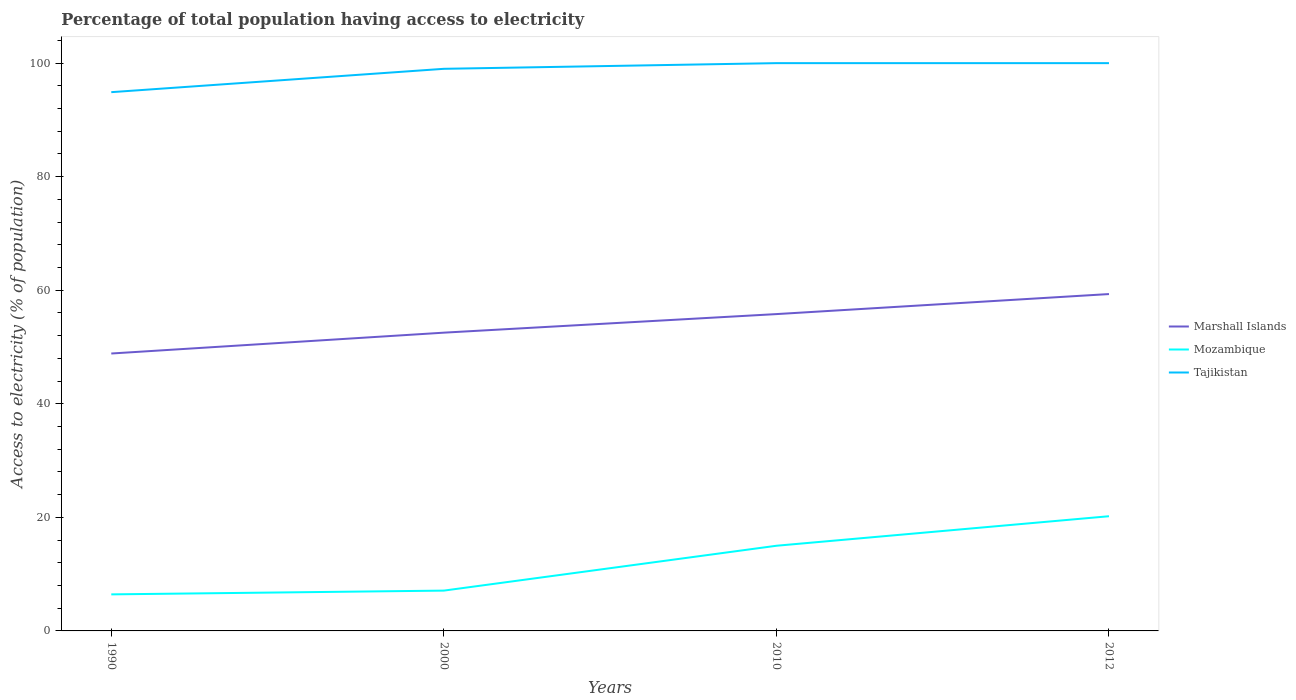Across all years, what is the maximum percentage of population that have access to electricity in Mozambique?
Provide a short and direct response. 6.44. In which year was the percentage of population that have access to electricity in Mozambique maximum?
Ensure brevity in your answer.  1990. What is the total percentage of population that have access to electricity in Marshall Islands in the graph?
Your response must be concise. -10.47. What is the difference between the highest and the second highest percentage of population that have access to electricity in Tajikistan?
Offer a very short reply. 5.11. What is the difference between the highest and the lowest percentage of population that have access to electricity in Mozambique?
Provide a succinct answer. 2. How many years are there in the graph?
Keep it short and to the point. 4. What is the difference between two consecutive major ticks on the Y-axis?
Offer a terse response. 20. Are the values on the major ticks of Y-axis written in scientific E-notation?
Offer a terse response. No. Does the graph contain any zero values?
Provide a succinct answer. No. Does the graph contain grids?
Your answer should be compact. No. How many legend labels are there?
Keep it short and to the point. 3. How are the legend labels stacked?
Ensure brevity in your answer.  Vertical. What is the title of the graph?
Offer a terse response. Percentage of total population having access to electricity. What is the label or title of the Y-axis?
Your answer should be compact. Access to electricity (% of population). What is the Access to electricity (% of population) of Marshall Islands in 1990?
Offer a very short reply. 48.86. What is the Access to electricity (% of population) of Mozambique in 1990?
Your response must be concise. 6.44. What is the Access to electricity (% of population) of Tajikistan in 1990?
Ensure brevity in your answer.  94.89. What is the Access to electricity (% of population) of Marshall Islands in 2000?
Provide a succinct answer. 52.53. What is the Access to electricity (% of population) of Marshall Islands in 2010?
Offer a very short reply. 55.8. What is the Access to electricity (% of population) in Mozambique in 2010?
Provide a succinct answer. 15. What is the Access to electricity (% of population) of Marshall Islands in 2012?
Your answer should be very brief. 59.33. What is the Access to electricity (% of population) of Mozambique in 2012?
Your response must be concise. 20.2. Across all years, what is the maximum Access to electricity (% of population) of Marshall Islands?
Offer a very short reply. 59.33. Across all years, what is the maximum Access to electricity (% of population) of Mozambique?
Offer a very short reply. 20.2. Across all years, what is the minimum Access to electricity (% of population) in Marshall Islands?
Provide a short and direct response. 48.86. Across all years, what is the minimum Access to electricity (% of population) of Mozambique?
Provide a short and direct response. 6.44. Across all years, what is the minimum Access to electricity (% of population) of Tajikistan?
Provide a short and direct response. 94.89. What is the total Access to electricity (% of population) of Marshall Islands in the graph?
Your answer should be compact. 216.52. What is the total Access to electricity (% of population) in Mozambique in the graph?
Your response must be concise. 48.74. What is the total Access to electricity (% of population) in Tajikistan in the graph?
Keep it short and to the point. 393.89. What is the difference between the Access to electricity (% of population) in Marshall Islands in 1990 and that in 2000?
Make the answer very short. -3.67. What is the difference between the Access to electricity (% of population) in Mozambique in 1990 and that in 2000?
Your response must be concise. -0.66. What is the difference between the Access to electricity (% of population) in Tajikistan in 1990 and that in 2000?
Provide a short and direct response. -4.11. What is the difference between the Access to electricity (% of population) of Marshall Islands in 1990 and that in 2010?
Provide a short and direct response. -6.94. What is the difference between the Access to electricity (% of population) of Mozambique in 1990 and that in 2010?
Provide a succinct answer. -8.56. What is the difference between the Access to electricity (% of population) of Tajikistan in 1990 and that in 2010?
Provide a short and direct response. -5.11. What is the difference between the Access to electricity (% of population) in Marshall Islands in 1990 and that in 2012?
Offer a very short reply. -10.47. What is the difference between the Access to electricity (% of population) in Mozambique in 1990 and that in 2012?
Keep it short and to the point. -13.76. What is the difference between the Access to electricity (% of population) of Tajikistan in 1990 and that in 2012?
Your answer should be very brief. -5.11. What is the difference between the Access to electricity (% of population) of Marshall Islands in 2000 and that in 2010?
Your response must be concise. -3.27. What is the difference between the Access to electricity (% of population) in Tajikistan in 2000 and that in 2010?
Give a very brief answer. -1. What is the difference between the Access to electricity (% of population) in Marshall Islands in 2000 and that in 2012?
Provide a short and direct response. -6.8. What is the difference between the Access to electricity (% of population) of Mozambique in 2000 and that in 2012?
Give a very brief answer. -13.1. What is the difference between the Access to electricity (% of population) of Marshall Islands in 2010 and that in 2012?
Ensure brevity in your answer.  -3.53. What is the difference between the Access to electricity (% of population) of Mozambique in 2010 and that in 2012?
Your answer should be compact. -5.2. What is the difference between the Access to electricity (% of population) in Marshall Islands in 1990 and the Access to electricity (% of population) in Mozambique in 2000?
Your response must be concise. 41.76. What is the difference between the Access to electricity (% of population) in Marshall Islands in 1990 and the Access to electricity (% of population) in Tajikistan in 2000?
Provide a succinct answer. -50.14. What is the difference between the Access to electricity (% of population) of Mozambique in 1990 and the Access to electricity (% of population) of Tajikistan in 2000?
Provide a succinct answer. -92.56. What is the difference between the Access to electricity (% of population) in Marshall Islands in 1990 and the Access to electricity (% of population) in Mozambique in 2010?
Your answer should be compact. 33.86. What is the difference between the Access to electricity (% of population) in Marshall Islands in 1990 and the Access to electricity (% of population) in Tajikistan in 2010?
Your answer should be very brief. -51.14. What is the difference between the Access to electricity (% of population) of Mozambique in 1990 and the Access to electricity (% of population) of Tajikistan in 2010?
Provide a short and direct response. -93.56. What is the difference between the Access to electricity (% of population) in Marshall Islands in 1990 and the Access to electricity (% of population) in Mozambique in 2012?
Offer a very short reply. 28.66. What is the difference between the Access to electricity (% of population) of Marshall Islands in 1990 and the Access to electricity (% of population) of Tajikistan in 2012?
Make the answer very short. -51.14. What is the difference between the Access to electricity (% of population) in Mozambique in 1990 and the Access to electricity (% of population) in Tajikistan in 2012?
Provide a short and direct response. -93.56. What is the difference between the Access to electricity (% of population) in Marshall Islands in 2000 and the Access to electricity (% of population) in Mozambique in 2010?
Keep it short and to the point. 37.53. What is the difference between the Access to electricity (% of population) in Marshall Islands in 2000 and the Access to electricity (% of population) in Tajikistan in 2010?
Your answer should be very brief. -47.47. What is the difference between the Access to electricity (% of population) in Mozambique in 2000 and the Access to electricity (% of population) in Tajikistan in 2010?
Your answer should be compact. -92.9. What is the difference between the Access to electricity (% of population) in Marshall Islands in 2000 and the Access to electricity (% of population) in Mozambique in 2012?
Your answer should be compact. 32.33. What is the difference between the Access to electricity (% of population) of Marshall Islands in 2000 and the Access to electricity (% of population) of Tajikistan in 2012?
Offer a terse response. -47.47. What is the difference between the Access to electricity (% of population) of Mozambique in 2000 and the Access to electricity (% of population) of Tajikistan in 2012?
Your answer should be compact. -92.9. What is the difference between the Access to electricity (% of population) in Marshall Islands in 2010 and the Access to electricity (% of population) in Mozambique in 2012?
Ensure brevity in your answer.  35.6. What is the difference between the Access to electricity (% of population) of Marshall Islands in 2010 and the Access to electricity (% of population) of Tajikistan in 2012?
Make the answer very short. -44.2. What is the difference between the Access to electricity (% of population) of Mozambique in 2010 and the Access to electricity (% of population) of Tajikistan in 2012?
Your answer should be compact. -85. What is the average Access to electricity (% of population) in Marshall Islands per year?
Provide a succinct answer. 54.13. What is the average Access to electricity (% of population) in Mozambique per year?
Provide a succinct answer. 12.18. What is the average Access to electricity (% of population) of Tajikistan per year?
Give a very brief answer. 98.47. In the year 1990, what is the difference between the Access to electricity (% of population) of Marshall Islands and Access to electricity (% of population) of Mozambique?
Make the answer very short. 42.42. In the year 1990, what is the difference between the Access to electricity (% of population) in Marshall Islands and Access to electricity (% of population) in Tajikistan?
Provide a short and direct response. -46.03. In the year 1990, what is the difference between the Access to electricity (% of population) of Mozambique and Access to electricity (% of population) of Tajikistan?
Make the answer very short. -88.45. In the year 2000, what is the difference between the Access to electricity (% of population) in Marshall Islands and Access to electricity (% of population) in Mozambique?
Ensure brevity in your answer.  45.43. In the year 2000, what is the difference between the Access to electricity (% of population) of Marshall Islands and Access to electricity (% of population) of Tajikistan?
Make the answer very short. -46.47. In the year 2000, what is the difference between the Access to electricity (% of population) of Mozambique and Access to electricity (% of population) of Tajikistan?
Give a very brief answer. -91.9. In the year 2010, what is the difference between the Access to electricity (% of population) in Marshall Islands and Access to electricity (% of population) in Mozambique?
Offer a terse response. 40.8. In the year 2010, what is the difference between the Access to electricity (% of population) of Marshall Islands and Access to electricity (% of population) of Tajikistan?
Provide a short and direct response. -44.2. In the year 2010, what is the difference between the Access to electricity (% of population) of Mozambique and Access to electricity (% of population) of Tajikistan?
Offer a terse response. -85. In the year 2012, what is the difference between the Access to electricity (% of population) in Marshall Islands and Access to electricity (% of population) in Mozambique?
Your answer should be compact. 39.13. In the year 2012, what is the difference between the Access to electricity (% of population) in Marshall Islands and Access to electricity (% of population) in Tajikistan?
Offer a terse response. -40.67. In the year 2012, what is the difference between the Access to electricity (% of population) of Mozambique and Access to electricity (% of population) of Tajikistan?
Offer a very short reply. -79.8. What is the ratio of the Access to electricity (% of population) of Marshall Islands in 1990 to that in 2000?
Keep it short and to the point. 0.93. What is the ratio of the Access to electricity (% of population) of Mozambique in 1990 to that in 2000?
Keep it short and to the point. 0.91. What is the ratio of the Access to electricity (% of population) of Tajikistan in 1990 to that in 2000?
Offer a very short reply. 0.96. What is the ratio of the Access to electricity (% of population) of Marshall Islands in 1990 to that in 2010?
Offer a very short reply. 0.88. What is the ratio of the Access to electricity (% of population) of Mozambique in 1990 to that in 2010?
Make the answer very short. 0.43. What is the ratio of the Access to electricity (% of population) of Tajikistan in 1990 to that in 2010?
Provide a succinct answer. 0.95. What is the ratio of the Access to electricity (% of population) in Marshall Islands in 1990 to that in 2012?
Your answer should be compact. 0.82. What is the ratio of the Access to electricity (% of population) in Mozambique in 1990 to that in 2012?
Make the answer very short. 0.32. What is the ratio of the Access to electricity (% of population) of Tajikistan in 1990 to that in 2012?
Make the answer very short. 0.95. What is the ratio of the Access to electricity (% of population) in Marshall Islands in 2000 to that in 2010?
Provide a succinct answer. 0.94. What is the ratio of the Access to electricity (% of population) of Mozambique in 2000 to that in 2010?
Provide a short and direct response. 0.47. What is the ratio of the Access to electricity (% of population) of Tajikistan in 2000 to that in 2010?
Your answer should be compact. 0.99. What is the ratio of the Access to electricity (% of population) of Marshall Islands in 2000 to that in 2012?
Ensure brevity in your answer.  0.89. What is the ratio of the Access to electricity (% of population) in Mozambique in 2000 to that in 2012?
Offer a very short reply. 0.35. What is the ratio of the Access to electricity (% of population) in Marshall Islands in 2010 to that in 2012?
Your answer should be very brief. 0.94. What is the ratio of the Access to electricity (% of population) of Mozambique in 2010 to that in 2012?
Ensure brevity in your answer.  0.74. What is the ratio of the Access to electricity (% of population) of Tajikistan in 2010 to that in 2012?
Provide a succinct answer. 1. What is the difference between the highest and the second highest Access to electricity (% of population) in Marshall Islands?
Offer a very short reply. 3.53. What is the difference between the highest and the lowest Access to electricity (% of population) in Marshall Islands?
Provide a succinct answer. 10.47. What is the difference between the highest and the lowest Access to electricity (% of population) of Mozambique?
Provide a short and direct response. 13.76. What is the difference between the highest and the lowest Access to electricity (% of population) in Tajikistan?
Your response must be concise. 5.11. 